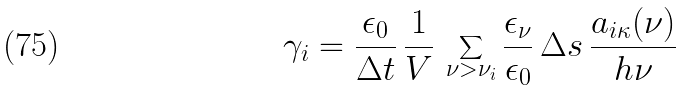<formula> <loc_0><loc_0><loc_500><loc_500>\gamma _ { i } = \frac { \epsilon _ { 0 } } { \Delta t } \, \frac { 1 } { V } \, \sum _ { \nu > \nu _ { i } } \frac { \epsilon _ { \nu } } { \epsilon _ { 0 } } \, \Delta s \, \frac { a _ { i \kappa } ( \nu ) } { h \nu }</formula> 